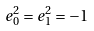Convert formula to latex. <formula><loc_0><loc_0><loc_500><loc_500>e _ { 0 } ^ { 2 } = e _ { 1 } ^ { 2 } = - 1</formula> 